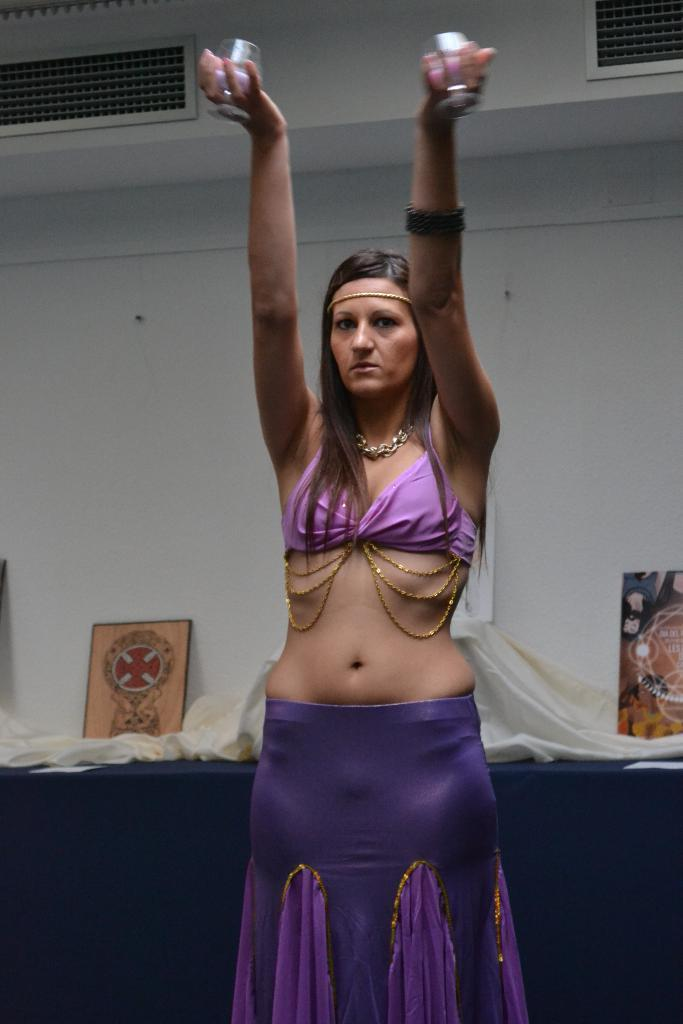What is the main subject of the image? There is a beautiful woman in the image. What is the woman doing with her hands? The woman is raising her 2 hands. What color is the dress the woman is wearing? The woman is wearing a purple dress. What can be seen behind the woman in the image? There is a wall behind the woman. Reasoning: Let' Let's think step by step in order to produce the conversation. We start by identifying the main subject of the image, which is the beautiful woman. Then, we describe her actions, specifically what she is doing with her hands. Next, we mention the color of her dress to provide more detail about her appearance. Finally, we describe the background of the image, which is a wall. Absurd Question/Answer: What type of station is visible in the image? There is no station present in the image. Can you tell me how many grandfathers are in the image? There are no grandfathers present in the image. 